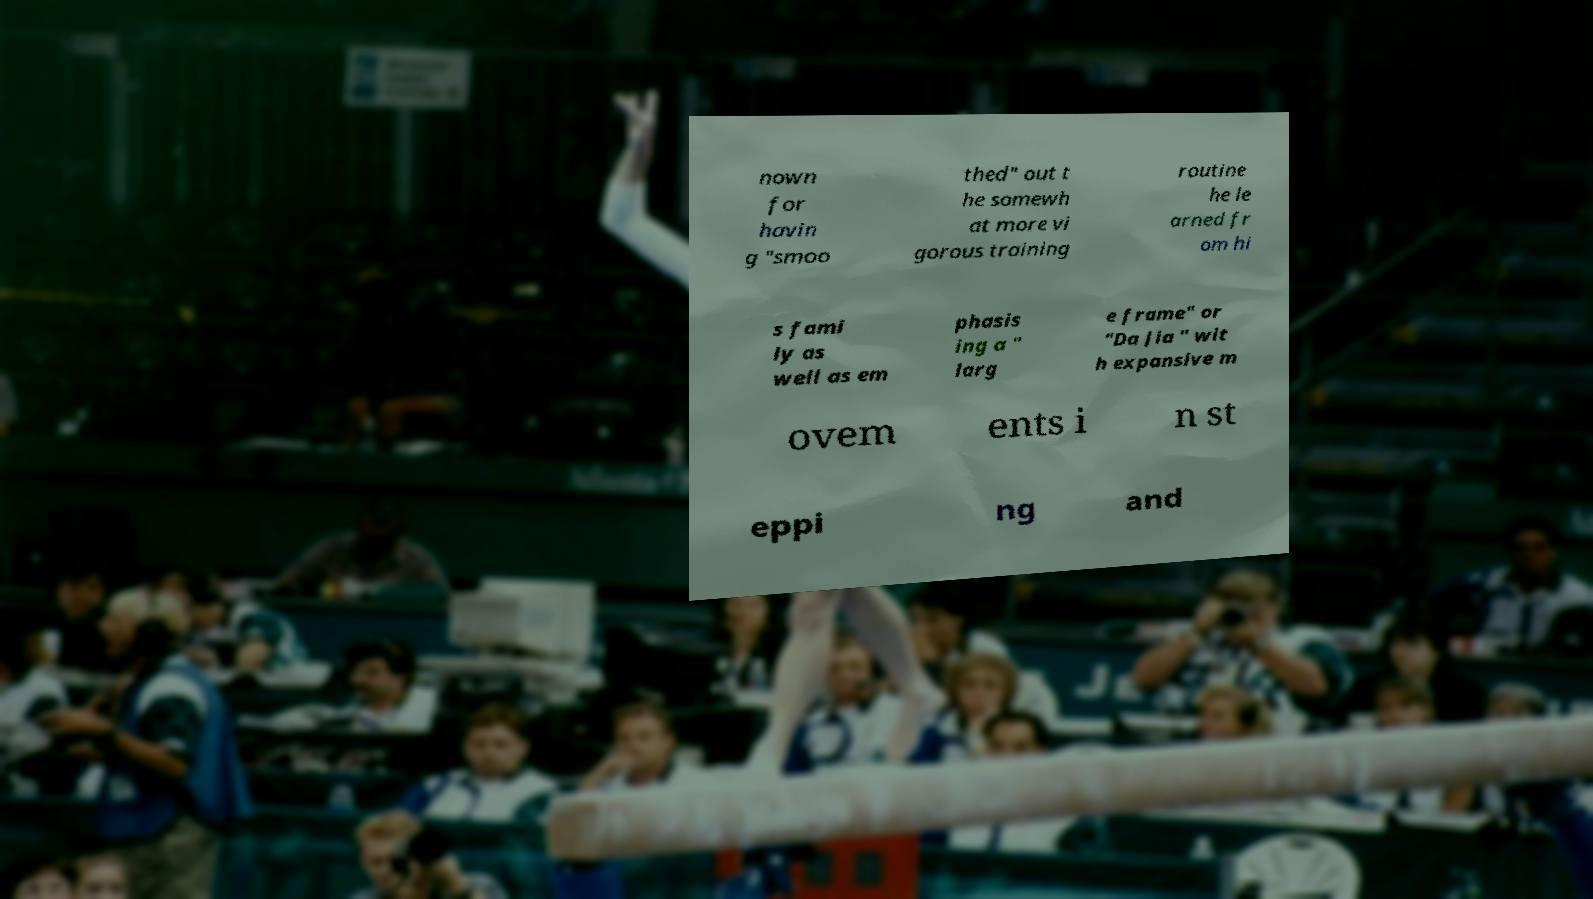Could you assist in decoding the text presented in this image and type it out clearly? nown for havin g "smoo thed" out t he somewh at more vi gorous training routine he le arned fr om hi s fami ly as well as em phasis ing a " larg e frame" or "Da Jia " wit h expansive m ovem ents i n st eppi ng and 